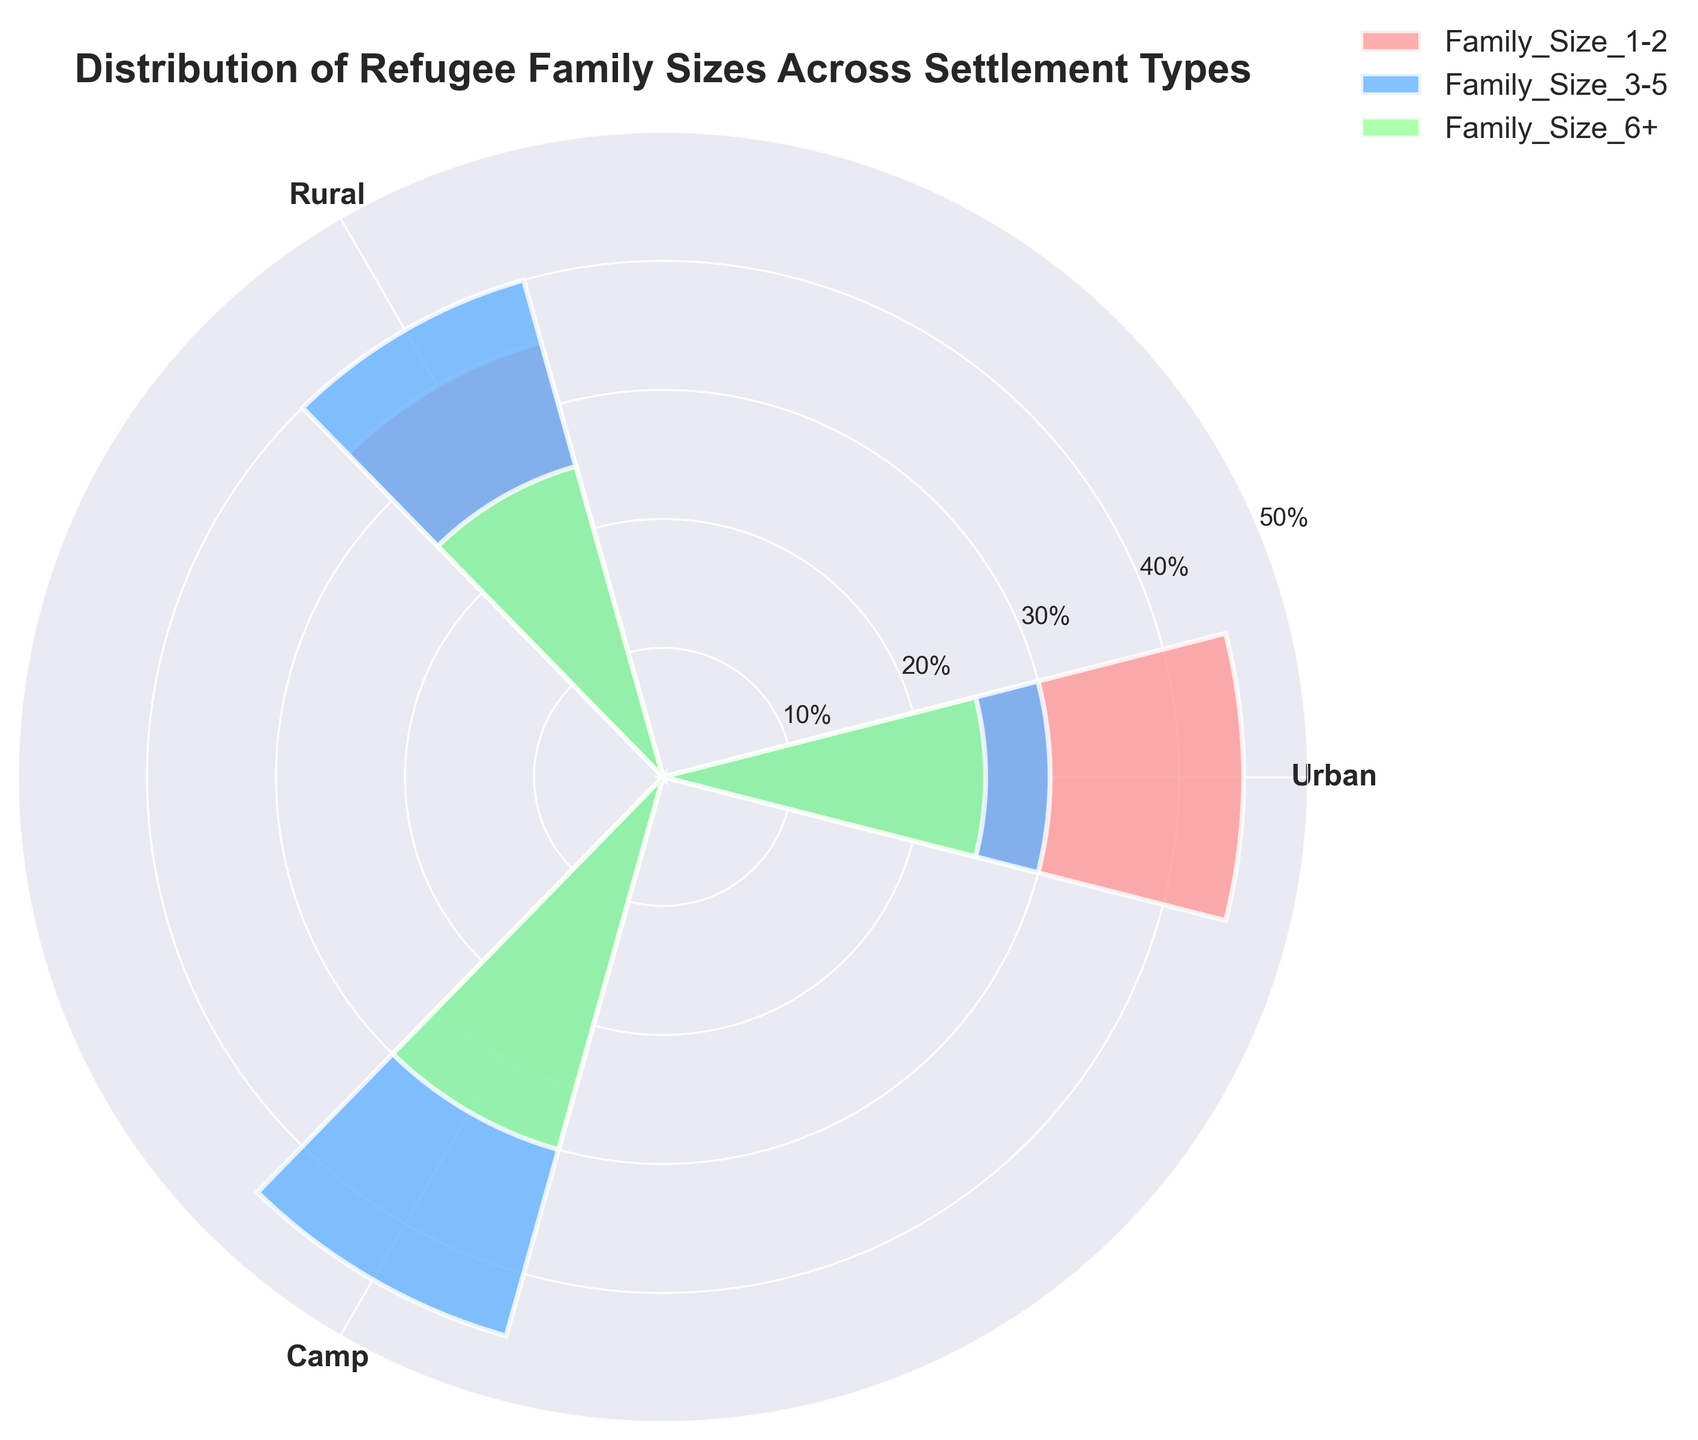What's the title of the figure? The title is usually located at the top of the figure and provides a description of what the figure is about.
Answer: Distribution of Refugee Family Sizes Across Settlement Types How many settlement types are represented in the figure? The angular division of the rose chart, corresponding to the unique categories provided on the plot, there are three settlement types. These are "Urban", "Rural", and "Camp".
Answer: 3 Which family size group is the least common in Urban settlements? To find the least common family size in Urban settlements, look at the height of the bars corresponding to Urban across different family sizes. Family Size 6+ has the lowest bar height in Urban settlements.
Answer: Family Size 6+ What is the total number of families in Rural settlements? Add the values represented by the bars for Rural: Family_Size_1-2 (35) + Family_Size_3-5 (40) + Family_Size_6+ (25). So, the total is 35 + 40 + 25 = 100.
Answer: 100 In which settlement type is the Family_Size_3-5 the highest? Compare the heights of the bars labeled Family_Size_3-5 across Urban, Rural, and Camp. The highest bar is for Camp, with a value of 45.
Answer: Camp What's the difference in the number of Family_Size_1-2 families between Urban and Rural settlements? The number of Family_Size_1-2 in Urban is 45 and in Rural is 35. Subtract Rural from Urban: 45 - 35 = 10.
Answer: 10 Are there more families of size 6+ in Camps or Urban settlements? Compare the bar heights for Family_Size_6+ in both Camp and Urban settlements. Camp has 30, and Urban has 25. Therefore, there are more in Camp.
Answer: Camp Which family size group has the most families in Camp settlements? Look at the bars corresponding to Camp across different family sizes; the highest bar is for Family_Size_3-5, with a value of 45.
Answer: Family_Size_3-5 What percentage of families in Urban settlements are Family_Size_6+? The number of Family_Size_6+ in Urban is 25, and the total number of families in Urban is 100. The percentage is (25 / 100) * 100% = 25%.
Answer: 25% How does the distribution of family sizes compare between Urban and Rural settlements? Compare each family size's values in Urban and Rural settlements: 1-2: Urban (45), Rural (35); 3-5: Urban (30), Rural (40); 6+: Urban (25), Rural (25).
Answer: Urban has more 1-2 size families, Rural has more 3-5 size families, 6+ size families are equal 